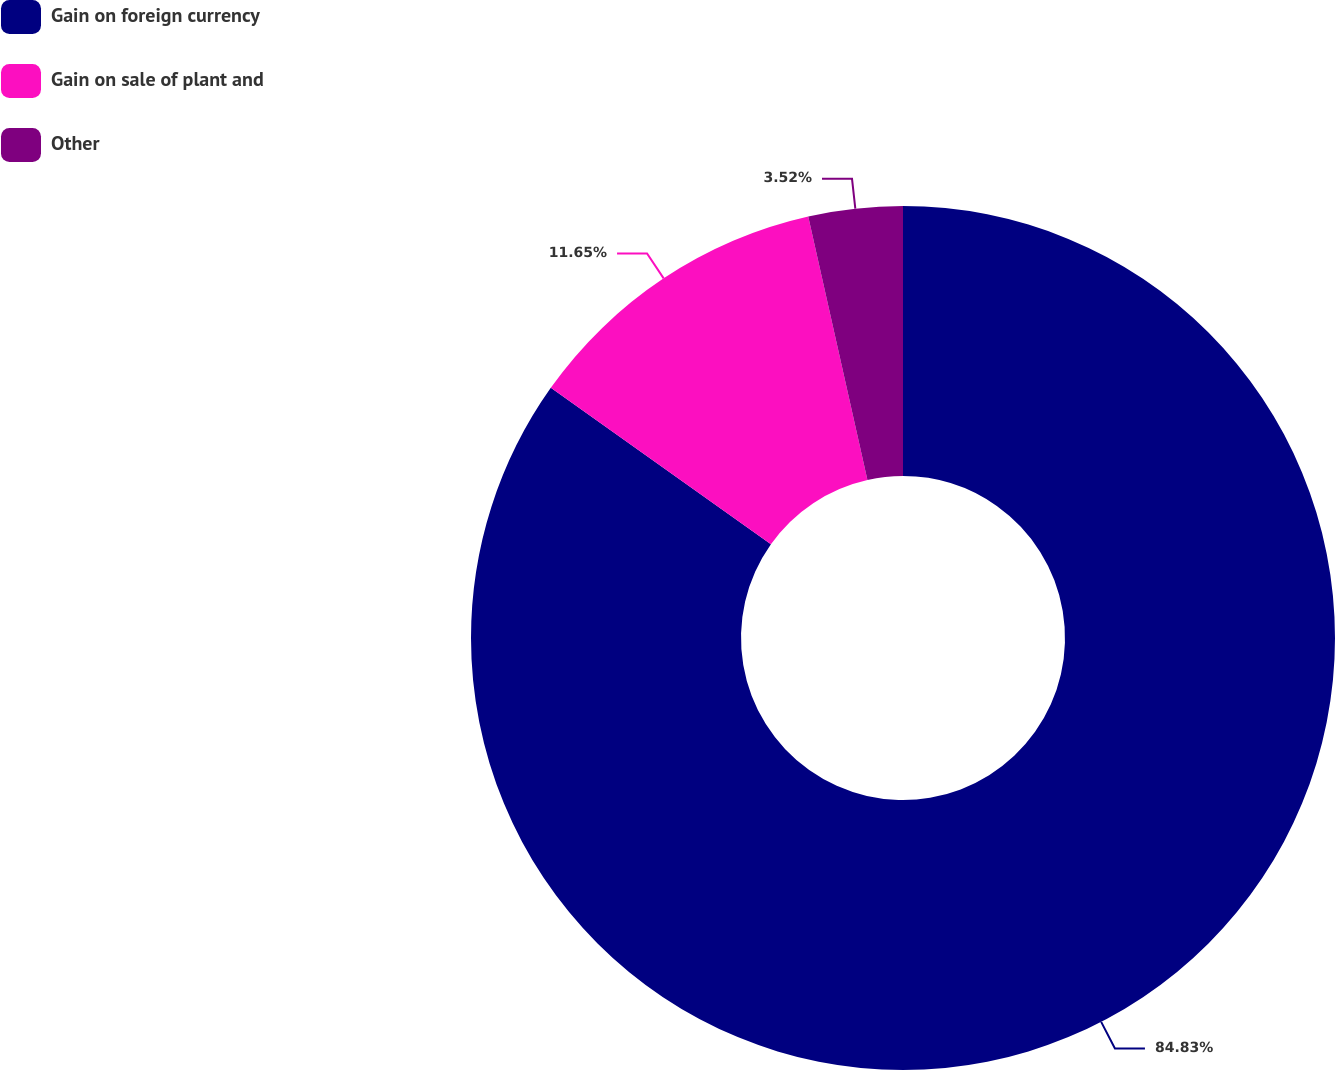<chart> <loc_0><loc_0><loc_500><loc_500><pie_chart><fcel>Gain on foreign currency<fcel>Gain on sale of plant and<fcel>Other<nl><fcel>84.83%<fcel>11.65%<fcel>3.52%<nl></chart> 